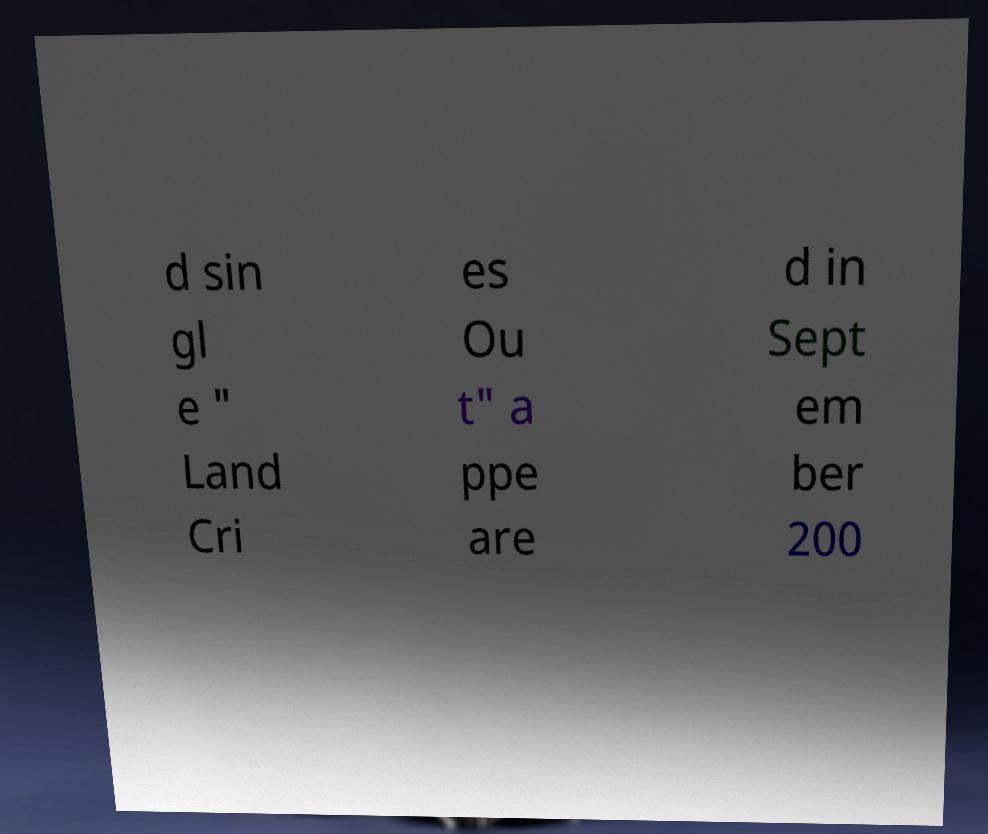What messages or text are displayed in this image? I need them in a readable, typed format. d sin gl e " Land Cri es Ou t" a ppe are d in Sept em ber 200 